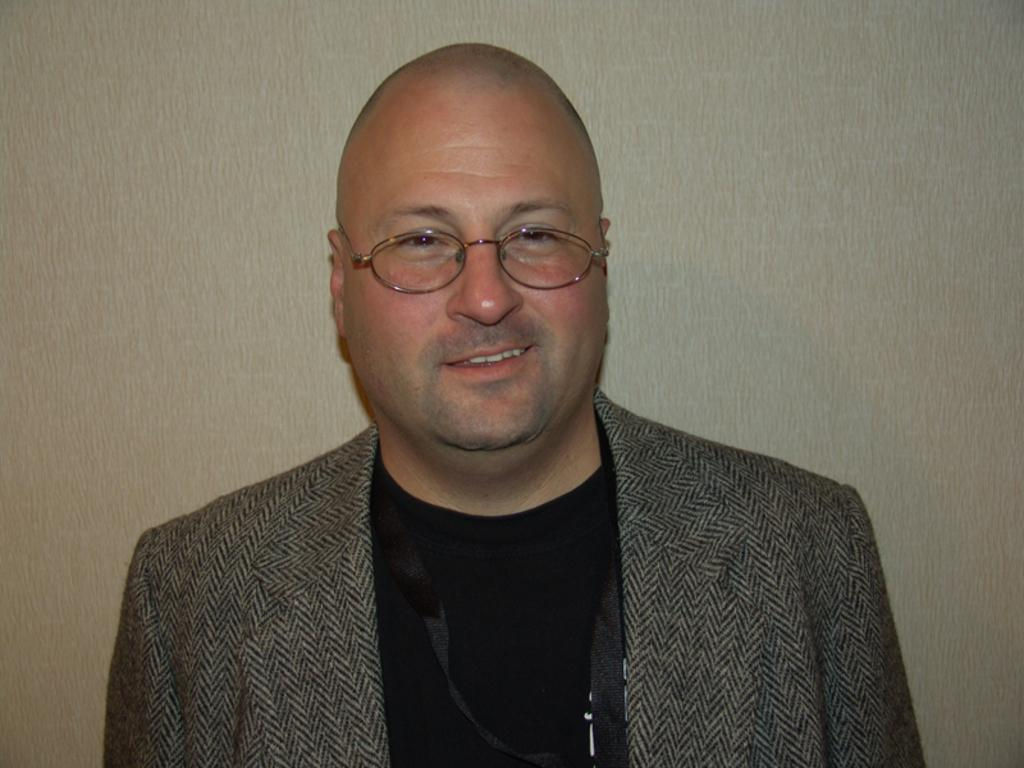What is the main subject of the image? The main subject of the image is a man. What is the man wearing on his upper body? The man is wearing a black t-shirt, a grey blazer, and a sweater. Where is the man positioned in the image? The man is standing near a wall. What is the weight of the scale in the image? There is no scale present in the image, so it is not possible to determine its weight. 